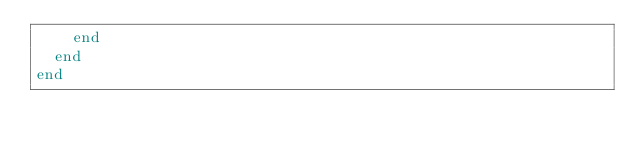Convert code to text. <code><loc_0><loc_0><loc_500><loc_500><_Ruby_>    end
  end
end
</code> 